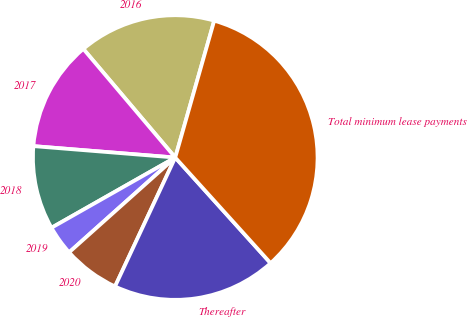<chart> <loc_0><loc_0><loc_500><loc_500><pie_chart><fcel>2016<fcel>2017<fcel>2018<fcel>2019<fcel>2020<fcel>Thereafter<fcel>Total minimum lease payments<nl><fcel>15.59%<fcel>12.54%<fcel>9.49%<fcel>3.39%<fcel>6.44%<fcel>18.64%<fcel>33.89%<nl></chart> 